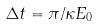<formula> <loc_0><loc_0><loc_500><loc_500>\Delta t = \pi / \kappa E _ { 0 }</formula> 